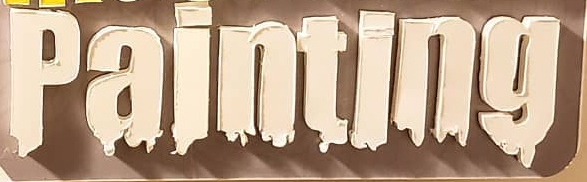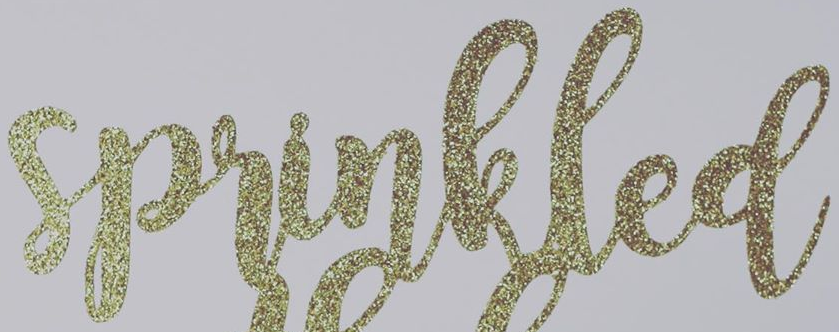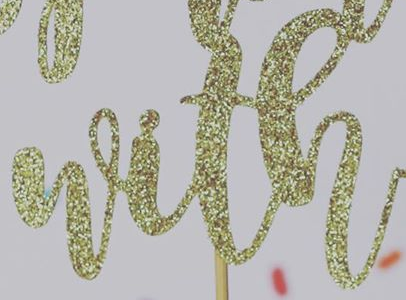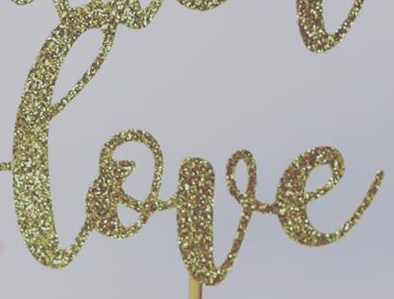Identify the words shown in these images in order, separated by a semicolon. painting; sprinkled; with; love 